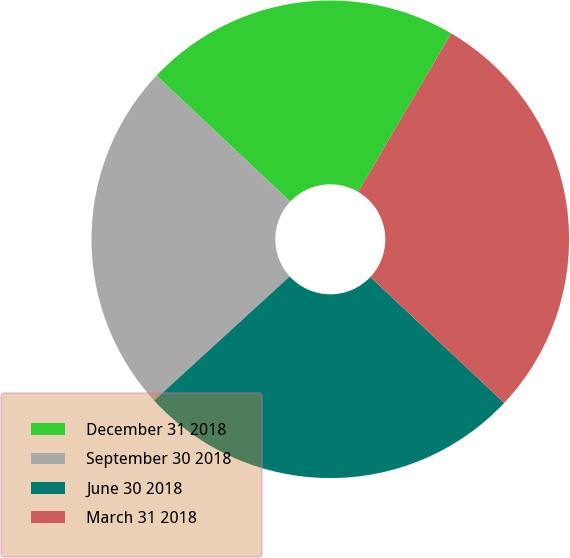Convert chart to OTSL. <chart><loc_0><loc_0><loc_500><loc_500><pie_chart><fcel>December 31 2018<fcel>September 30 2018<fcel>June 30 2018<fcel>March 31 2018<nl><fcel>21.43%<fcel>23.81%<fcel>26.19%<fcel>28.57%<nl></chart> 